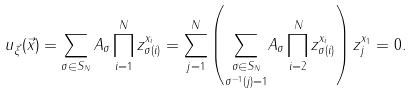<formula> <loc_0><loc_0><loc_500><loc_500>u _ { \vec { \xi } } ( \vec { x } ) = \sum _ { \sigma \in S _ { N } } A _ { \sigma } \prod _ { i = 1 } ^ { N } z _ { \sigma ( i ) } ^ { x _ { i } } = \sum _ { j = 1 } ^ { N } \left ( \underset { \sigma ^ { - 1 } ( j ) = 1 } { \sum _ { \sigma \in S _ { N } } } A _ { \sigma } \prod _ { i = 2 } ^ { N } z _ { \sigma ( i ) } ^ { x _ { i } } \right ) z _ { j } ^ { x _ { 1 } } = 0 .</formula> 